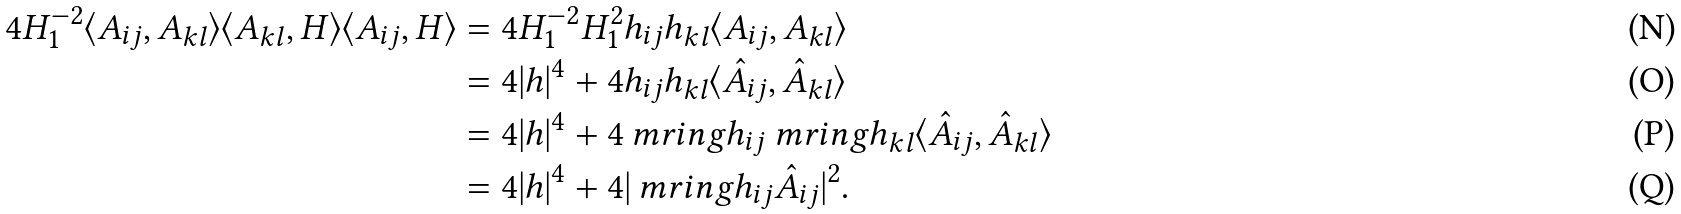Convert formula to latex. <formula><loc_0><loc_0><loc_500><loc_500>4 H _ { 1 } ^ { - 2 } \langle A _ { i j } , A _ { k l } \rangle \langle A _ { k l } , H \rangle \langle A _ { i j } , H \rangle & = 4 H _ { 1 } ^ { - 2 } H _ { 1 } ^ { 2 } h _ { i j } h _ { k l } \langle A _ { i j } , A _ { k l } \rangle \\ & = 4 | h | ^ { 4 } + 4 h _ { i j } h _ { k l } \langle \hat { A } _ { i j } , \hat { A } _ { k l } \rangle \\ & = 4 | h | ^ { 4 } + 4 \ m r i n g h _ { i j } \ m r i n g h _ { k l } \langle \hat { A } _ { i j } , \hat { A } _ { k l } \rangle \\ & = 4 | h | ^ { 4 } + 4 | \ m r i n g h _ { i j } \hat { A } _ { i j } | ^ { 2 } .</formula> 